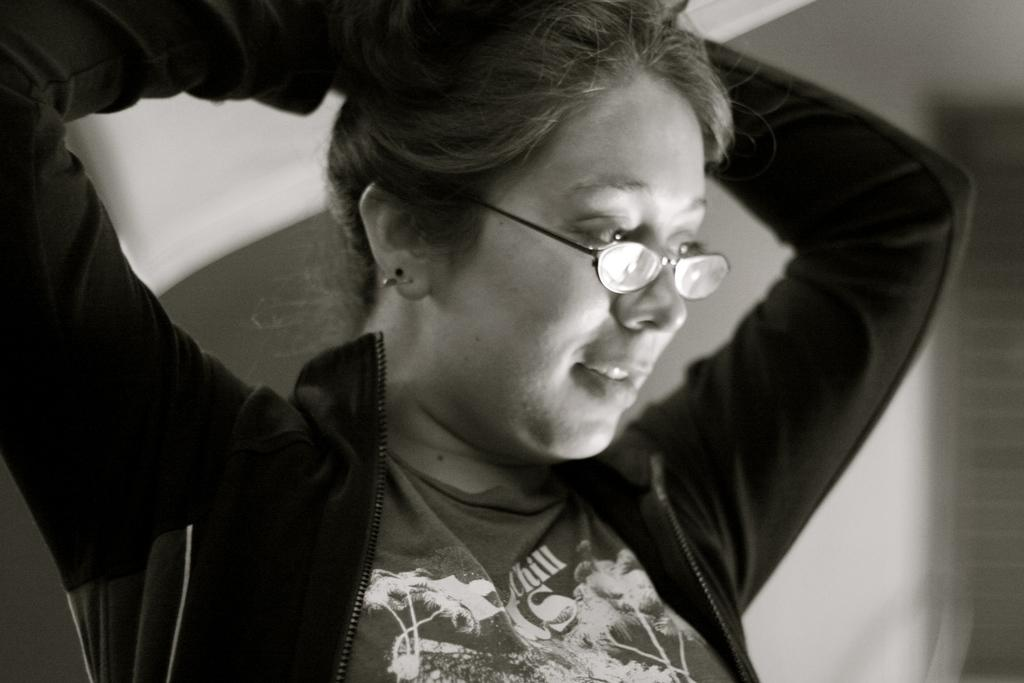Who is the main subject in the image? There is a lady in the center of the image. What is the lady wearing in the image? The lady is wearing spectacles. What type of credit can be seen on the floor in the image? There is no credit visible on the floor in the image. What color is the cloud in the image? There are no clouds present in the image. 